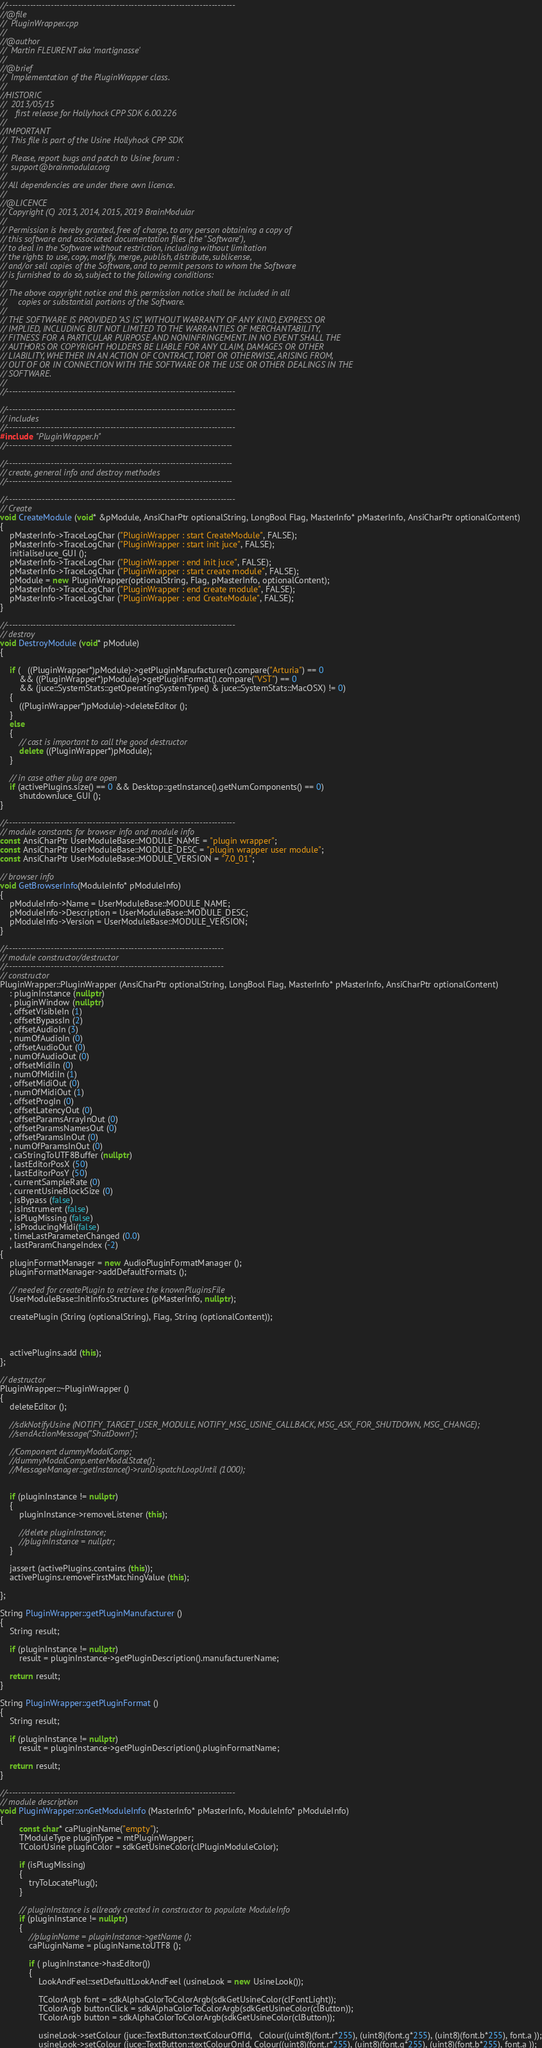<code> <loc_0><loc_0><loc_500><loc_500><_C++_>//-----------------------------------------------------------------------------
//@file  
//	PluginWrapper.cpp
//
//@author
//	Martin FLEURENT aka 'martignasse'
//
//@brief 
//	Implementation of the PluginWrapper class.
//
//HISTORIC 
//	2013/05/15
//    first release for Hollyhock CPP SDK 6.00.226 
//
//IMPORTANT
//	This file is part of the Usine Hollyhock CPP SDK
//
//  Please, report bugs and patch to Usine forum :
//  support@brainmodular.org 
//
// All dependencies are under there own licence.
//
//@LICENCE
// Copyright (C) 2013, 2014, 2015, 2019 BrainModular
// 
// Permission is hereby granted, free of charge, to any person obtaining a copy of 
// this software and associated documentation files (the "Software"), 
// to deal in the Software without restriction, including without limitation 
// the rights to use, copy, modify, merge, publish, distribute, sublicense, 
// and/or sell copies of the Software, and to permit persons to whom the Software 
// is furnished to do so, subject to the following conditions:
// 
// The above copyright notice and this permission notice shall be included in all 
//     copies or substantial portions of the Software.
// 
// THE SOFTWARE IS PROVIDED "AS IS", WITHOUT WARRANTY OF ANY KIND, EXPRESS OR 
// IMPLIED, INCLUDING BUT NOT LIMITED TO THE WARRANTIES OF MERCHANTABILITY, 
// FITNESS FOR A PARTICULAR PURPOSE AND NONINFRINGEMENT. IN NO EVENT SHALL THE 
// AUTHORS OR COPYRIGHT HOLDERS BE LIABLE FOR ANY CLAIM, DAMAGES OR OTHER 
// LIABILITY, WHETHER IN AN ACTION OF CONTRACT, TORT OR OTHERWISE, ARISING FROM, 
// OUT OF OR IN CONNECTION WITH THE SOFTWARE OR THE USE OR OTHER DEALINGS IN THE 
// SOFTWARE.
//
//-----------------------------------------------------------------------------

//-----------------------------------------------------------------------------
// includes
//-----------------------------------------------------------------------------
#include "PluginWrapper.h"
//----------------------------------------------------------------------------

//----------------------------------------------------------------------------
// create, general info and destroy methodes
//----------------------------------------------------------------------------

//-----------------------------------------------------------------------------
// Create
void CreateModule (void* &pModule, AnsiCharPtr optionalString, LongBool Flag, MasterInfo* pMasterInfo, AnsiCharPtr optionalContent) 
{
    pMasterInfo->TraceLogChar ("PluginWrapper : start CreateModule", FALSE);
    pMasterInfo->TraceLogChar ("PluginWrapper : start init juce", FALSE);
	initialiseJuce_GUI ();
    pMasterInfo->TraceLogChar ("PluginWrapper : end init juce", FALSE);
    pMasterInfo->TraceLogChar ("PluginWrapper : start create module", FALSE);
	pModule = new PluginWrapper(optionalString, Flag, pMasterInfo, optionalContent);
    pMasterInfo->TraceLogChar ("PluginWrapper : end create module", FALSE);
    pMasterInfo->TraceLogChar ("PluginWrapper : end CreateModule", FALSE);
}

//-----------------------------------------------------------------------------
// destroy
void DestroyModule (void* pModule) 
{
    
    if (   ((PluginWrapper*)pModule)->getPluginManufacturer().compare("Arturia") == 0
        && ((PluginWrapper*)pModule)->getPluginFormat().compare("VST") == 0
		&& (juce::SystemStats::getOperatingSystemType() & juce::SystemStats::MacOSX) != 0)
    {
        ((PluginWrapper*)pModule)->deleteEditor ();
    }
    else
    {
        // cast is important to call the good destructor
        delete ((PluginWrapper*)pModule);
    }
    
	// in case other plug are open
	if (activePlugins.size() == 0 && Desktop::getInstance().getNumComponents() == 0)
		shutdownJuce_GUI ();
}

//-----------------------------------------------------------------------------
// module constants for browser info and module info
const AnsiCharPtr UserModuleBase::MODULE_NAME = "plugin wrapper";
const AnsiCharPtr UserModuleBase::MODULE_DESC = "plugin wrapper user module";
const AnsiCharPtr UserModuleBase::MODULE_VERSION = "7.0_01";

// browser info
void GetBrowserInfo(ModuleInfo* pModuleInfo)
{
	pModuleInfo->Name = UserModuleBase::MODULE_NAME;
	pModuleInfo->Description = UserModuleBase::MODULE_DESC;
	pModuleInfo->Version = UserModuleBase::MODULE_VERSION;
}

//-------------------------------------------------------------------------
// module constructor/destructor
//-------------------------------------------------------------------------
// constructor
PluginWrapper::PluginWrapper (AnsiCharPtr optionalString, LongBool Flag, MasterInfo* pMasterInfo, AnsiCharPtr optionalContent) 
	: pluginInstance (nullptr)
	, pluginWindow (nullptr)
	, offsetVisibleIn (1)
	, offsetBypassIn (2)
	, offsetAudioIn (3)
	, numOfAudioIn (0)
	, offsetAudioOut (0)
	, numOfAudioOut (0)
	, offsetMidiIn (0)
	, numOfMidiIn (1)
	, offsetMidiOut (0)
	, numOfMidiOut (1)
	, offsetProgIn (0)
	, offsetLatencyOut (0)
	, offsetParamsArrayInOut (0)
	, offsetParamsNamesOut (0)
	, offsetParamsInOut (0)
	, numOfParamsInOut (0)
	, caStringToUTF8Buffer (nullptr)
	, lastEditorPosX (50)
	, lastEditorPosY (50)
	, currentSampleRate (0)
	, currentUsineBlockSize (0)
	, isBypass (false)
	, isInstrument (false)
	, isPlugMissing (false)
	, isProducingMidi(false)
    , timeLastParameterChanged (0.0)
    , lastParamChangeIndex (-2)
{
	pluginFormatManager = new AudioPluginFormatManager ();
	pluginFormatManager->addDefaultFormats ();
        
    // needed for createPlugin to retrieve the knownPluginsFile
	UserModuleBase::InitInfosStructures (pMasterInfo, nullptr);

	createPlugin (String (optionalString), Flag, String (optionalContent));
    
    
    
	activePlugins.add (this);
};

// destructor
PluginWrapper::~PluginWrapper ()
{
	deleteEditor ();
    
    //sdkNotifyUsine (NOTIFY_TARGET_USER_MODULE, NOTIFY_MSG_USINE_CALLBACK, MSG_ASK_FOR_SHUTDOWN, MSG_CHANGE);
    //sendActionMessage("ShutDown");
    
    //Component dummyModalComp;
    //dummyModalComp.enterModalState();
    //MessageManager::getInstance()->runDispatchLoopUntil (1000);
    
    
	if (pluginInstance != nullptr)
    {
		pluginInstance->removeListener (this);
        
        //delete pluginInstance;
        //pluginInstance = nullptr;
    }
    
    jassert (activePlugins.contains (this));
    activePlugins.removeFirstMatchingValue (this);
    
};

String PluginWrapper::getPluginManufacturer ()
{
    String result;
    
    if (pluginInstance != nullptr)
        result = pluginInstance->getPluginDescription().manufacturerName;
    
    return result;
}

String PluginWrapper::getPluginFormat ()
{
    String result;
    
    if (pluginInstance != nullptr)
        result = pluginInstance->getPluginDescription().pluginFormatName;
    
    return result;
}

//-----------------------------------------------------------------------------
// module description
void PluginWrapper::onGetModuleInfo (MasterInfo* pMasterInfo, ModuleInfo* pModuleInfo) 
{
		const char* caPluginName("empty"); 
		TModuleType pluginType = mtPluginWrapper;
		TColorUsine pluginColor = sdkGetUsineColor(clPluginModuleColor);

		if (isPlugMissing)
		{
			tryToLocatePlug();
		}

		// pluginInstance is allready created in constructor to populate ModuleInfo
		if (pluginInstance != nullptr)
		{
			//pluginName = pluginInstance->getName ();
			caPluginName = pluginName.toUTF8 ();

			if ( pluginInstance->hasEditor())
			{
				LookAndFeel::setDefaultLookAndFeel (usineLook = new UsineLook());

				TColorArgb font = sdkAlphaColorToColorArgb(sdkGetUsineColor(clFontLight));
				TColorArgb buttonClick = sdkAlphaColorToColorArgb(sdkGetUsineColor(clButton));
				TColorArgb button = sdkAlphaColorToColorArgb(sdkGetUsineColor(clButton));

				usineLook->setColour (juce::TextButton::textColourOffId,   Colour((uint8)(font.r*255), (uint8)(font.g*255), (uint8)(font.b*255), font.a ));
				usineLook->setColour (juce::TextButton::textColourOnId, Colour((uint8)(font.r*255), (uint8)(font.g*255), (uint8)(font.b*255), font.a ));</code> 